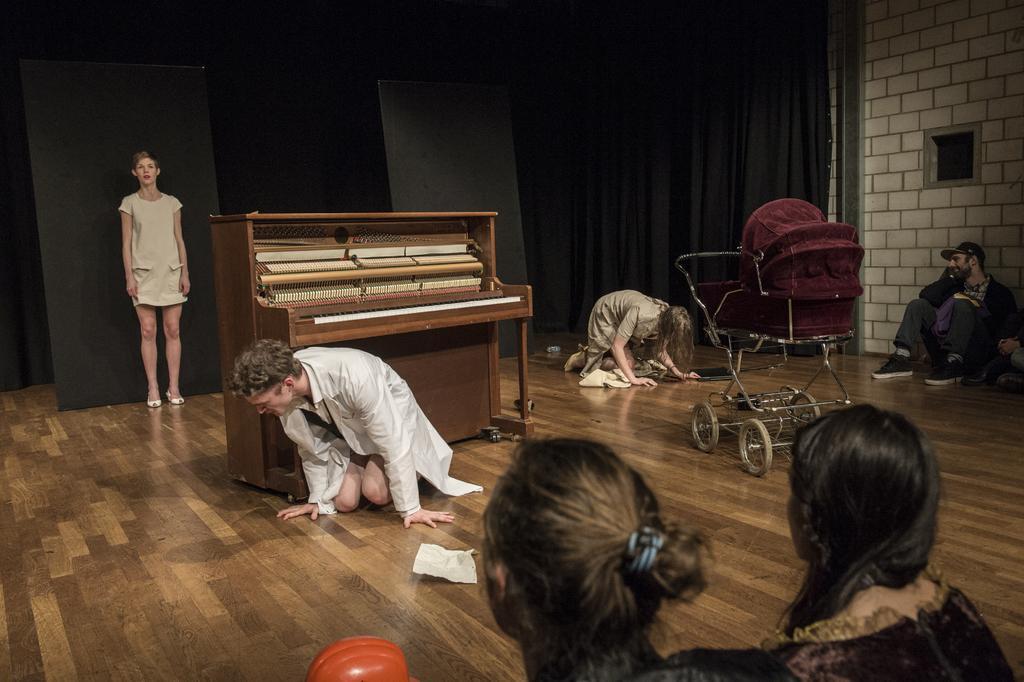Could you give a brief overview of what you see in this image? This curtain is in black color. This is a piano keyboard. This is a baby chair. On floor persons are sitting. This person is standing. 